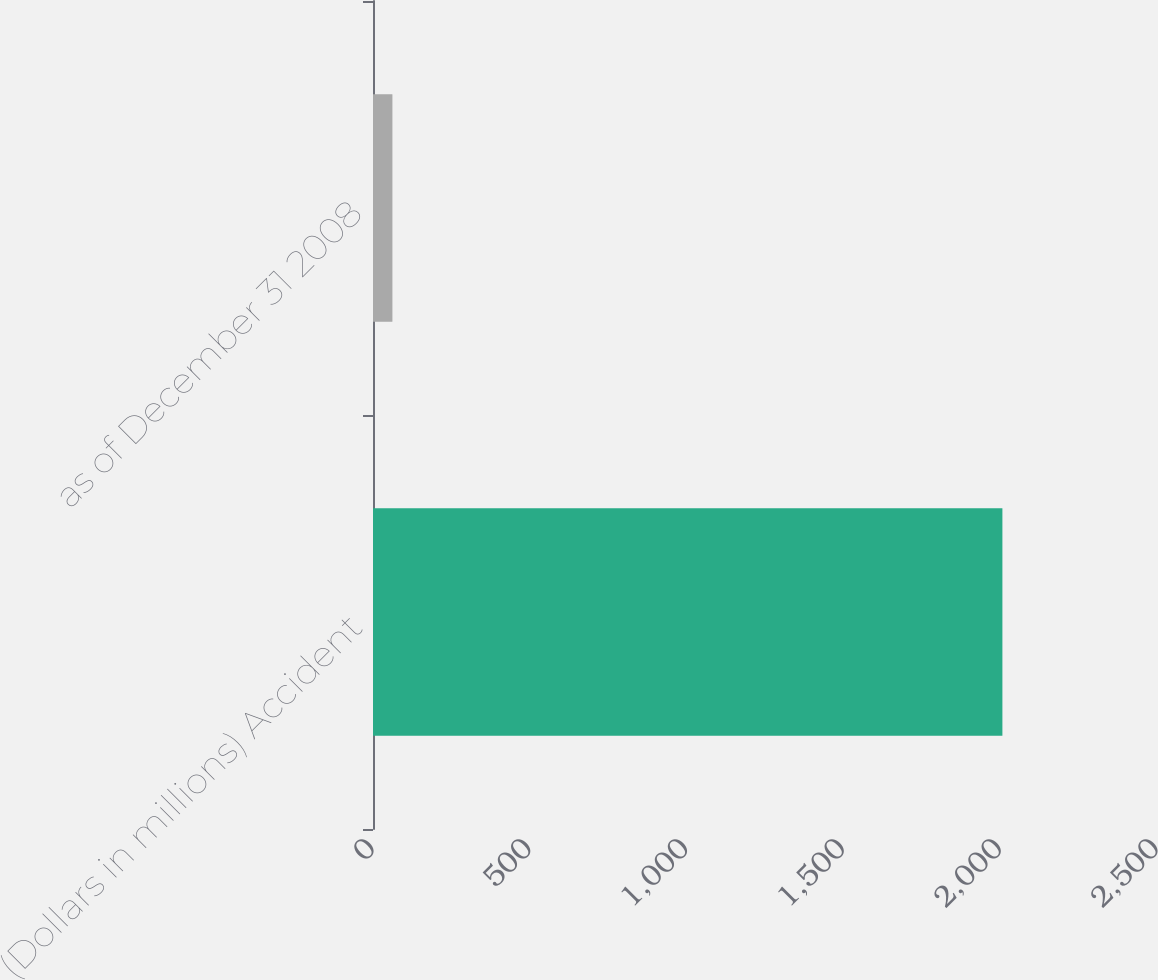Convert chart to OTSL. <chart><loc_0><loc_0><loc_500><loc_500><bar_chart><fcel>(Dollars in millions) Accident<fcel>as of December 31 2008<nl><fcel>2007<fcel>61.9<nl></chart> 